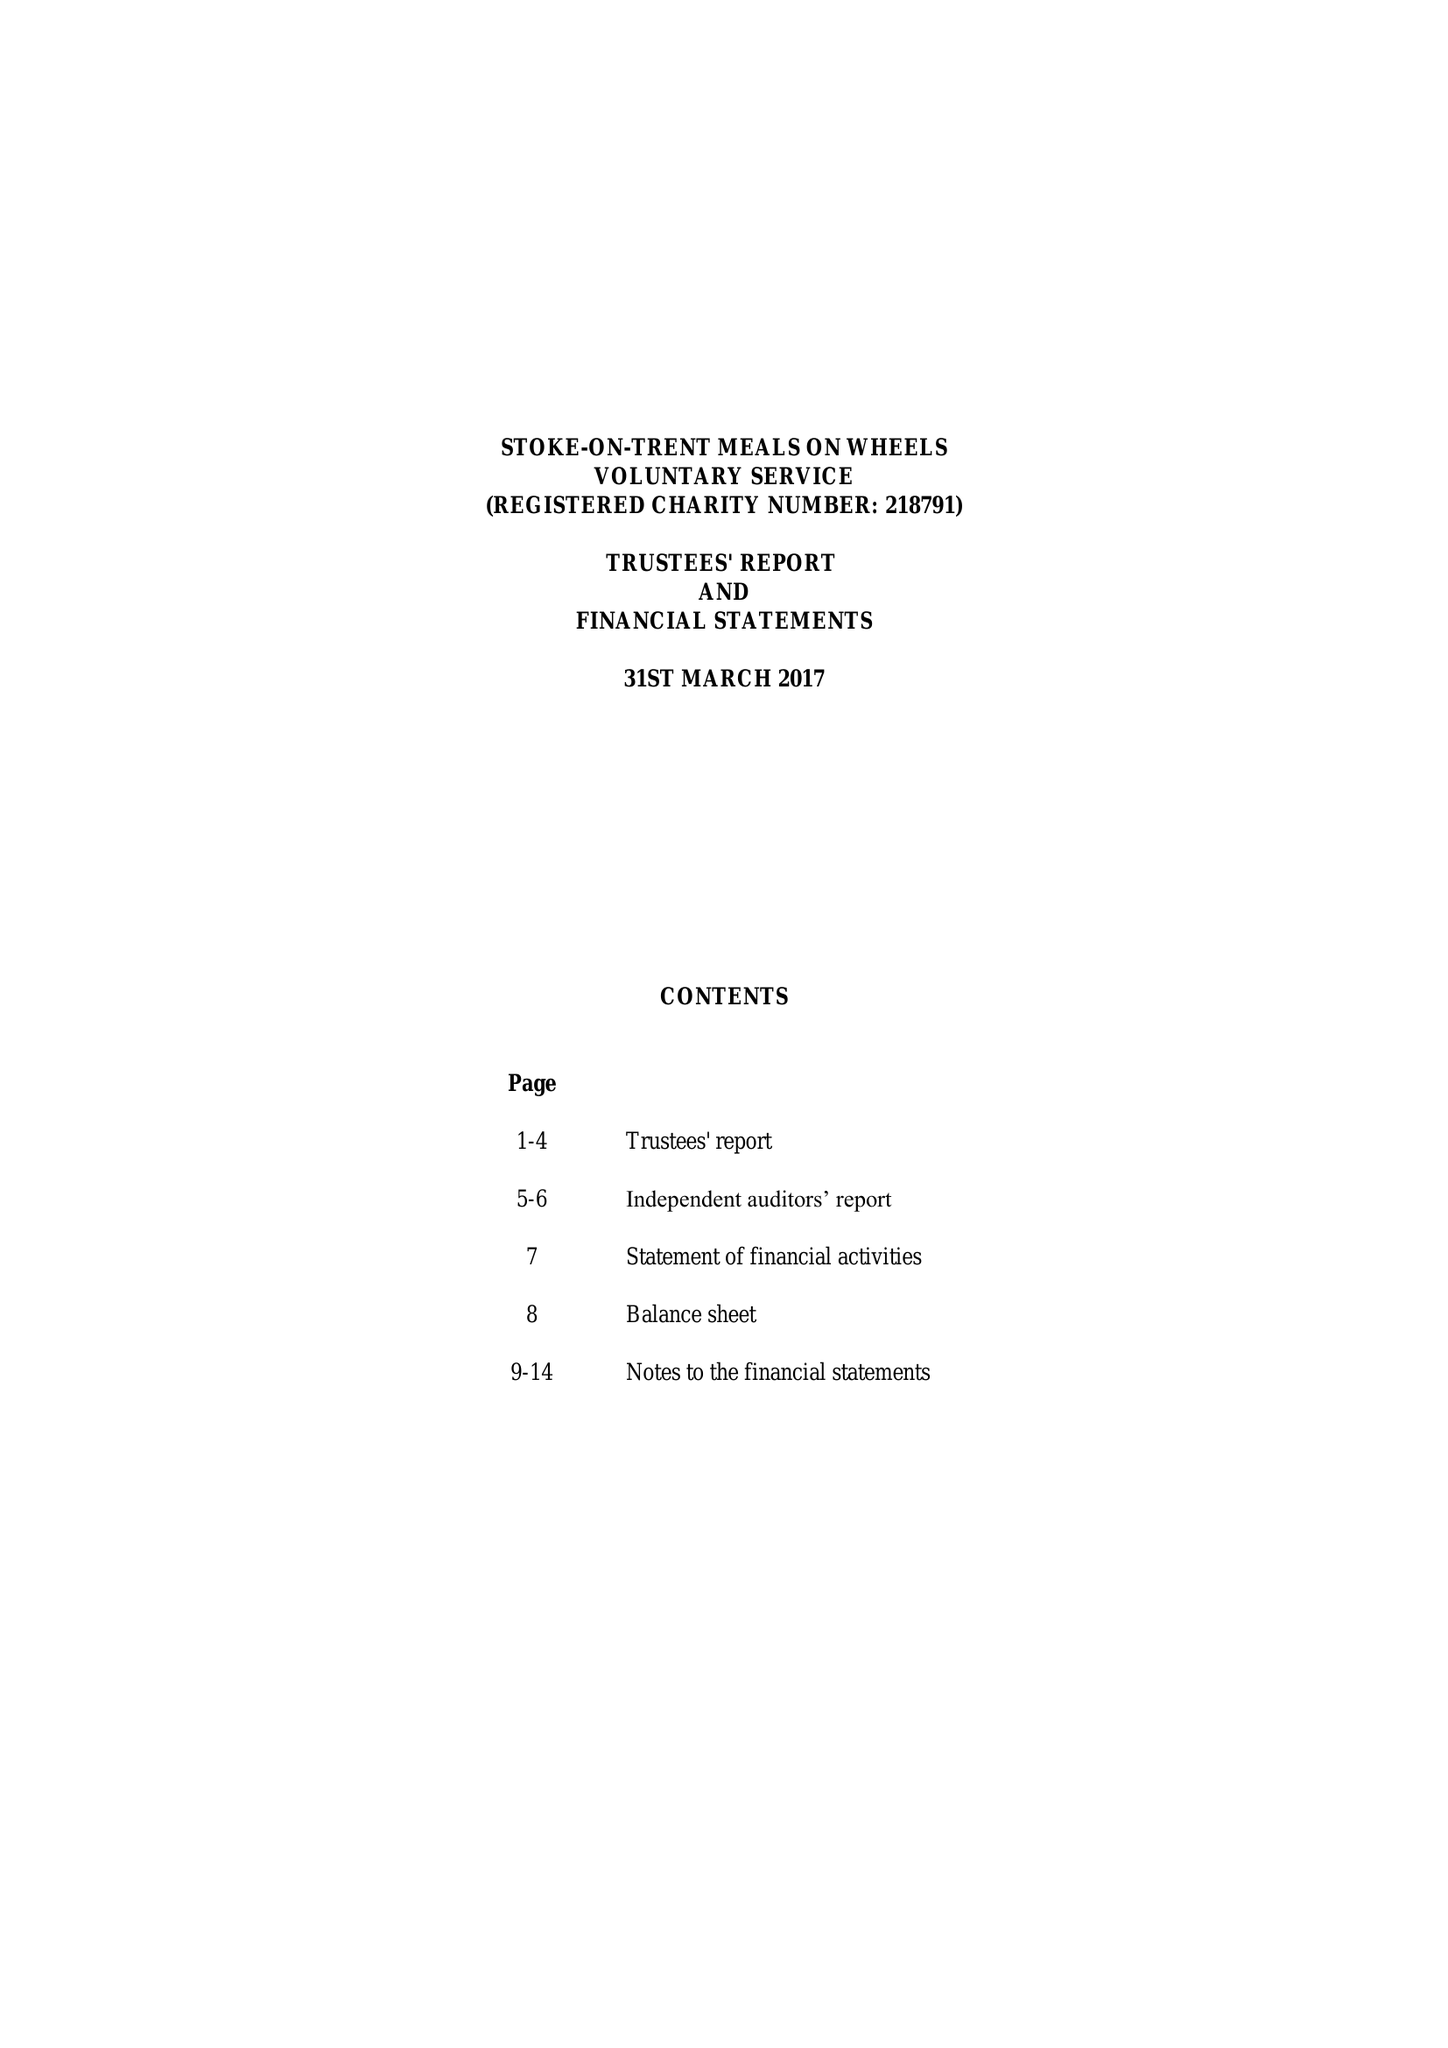What is the value for the charity_number?
Answer the question using a single word or phrase. 218791 